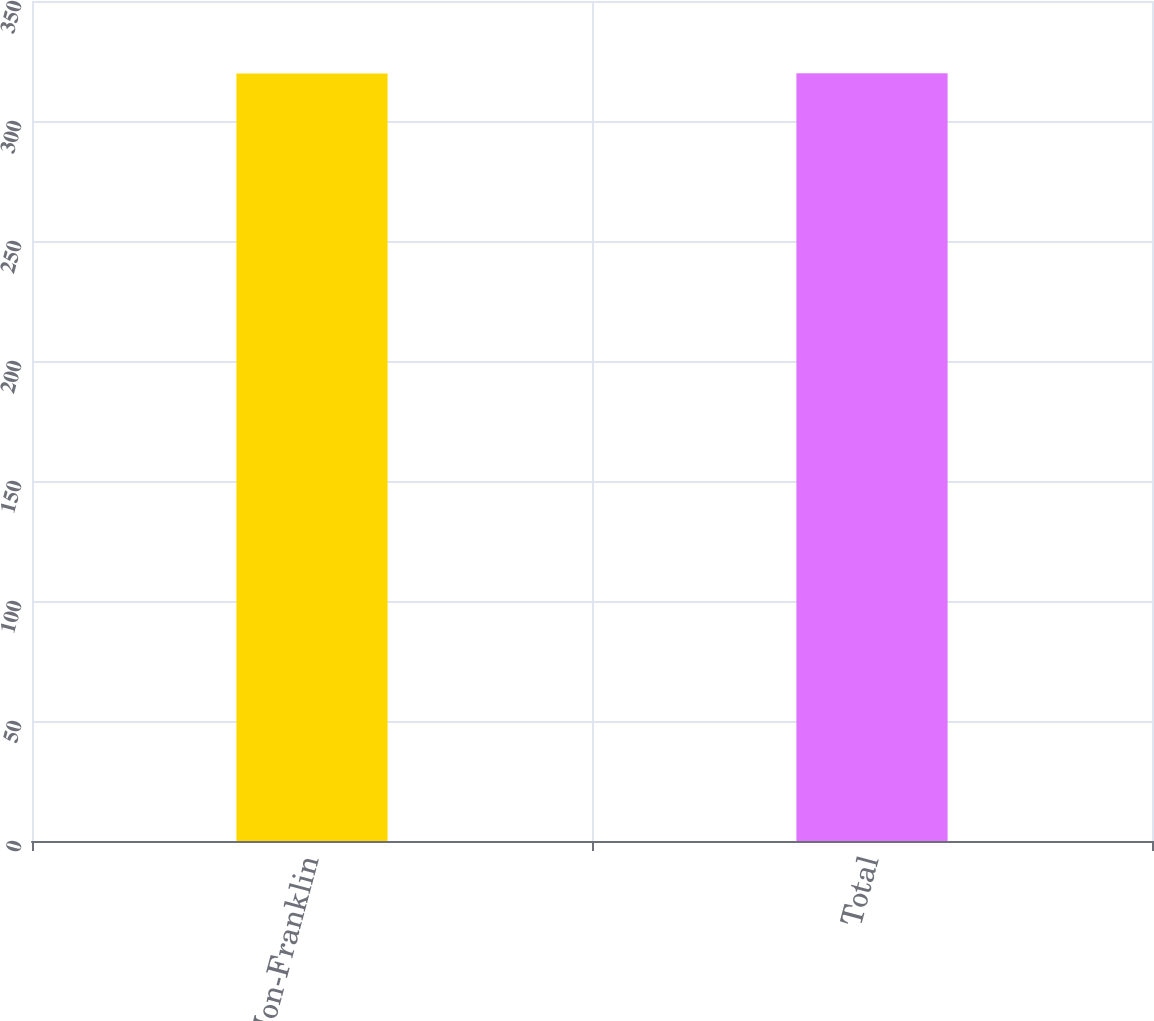Convert chart. <chart><loc_0><loc_0><loc_500><loc_500><bar_chart><fcel>Non-Franklin<fcel>Total<nl><fcel>319.8<fcel>319.9<nl></chart> 